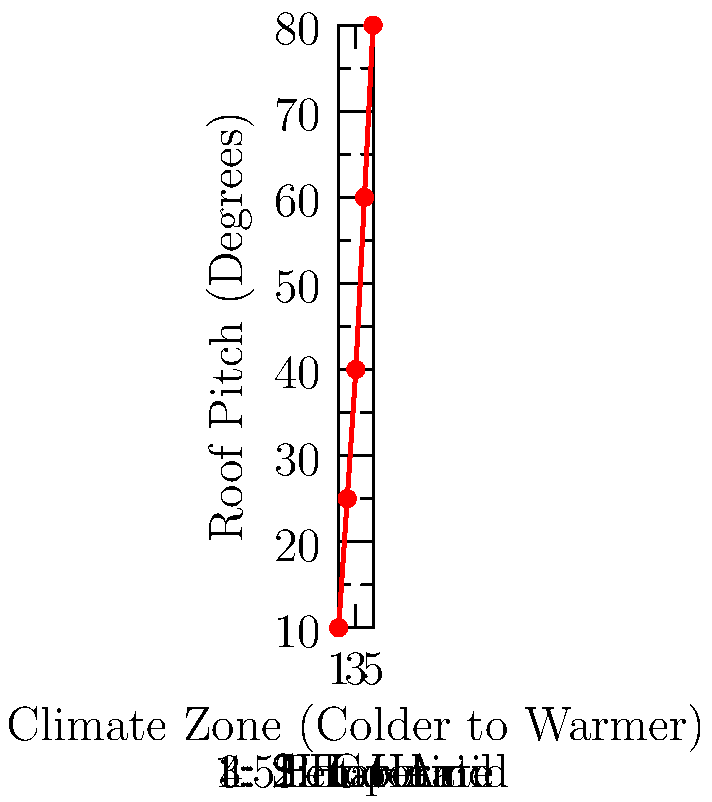Based on the graph showing the relationship between climate zones and roof pitch in American houses, what conclusion can be drawn about the correlation between regional climate and roof styles? To answer this question, let's analyze the graph step-by-step:

1. The x-axis represents climate zones, ranging from colder (1: Subarctic) to warmer (5: Hot-Arid).
2. The y-axis represents roof pitch in degrees, with higher values indicating steeper roofs.
3. The red line shows a clear upward trend from left to right.
4. In the Subarctic zone (1), the roof pitch is approximately 10°.
5. As we move to cooler climates (2), the pitch increases to about 25°.
6. In temperate regions (3), the pitch is around 40°.
7. Hot-Humid areas (4) show a roof pitch of about 60°.
8. Finally, in Hot-Arid regions (5), the roof pitch reaches its maximum at around 80°.

This trend indicates a positive correlation between warmer climates and steeper roof pitches. As we move from colder to warmer regions, the roof pitch increases significantly.

The reason for this correlation likely relates to climate-specific architectural adaptations:
- In colder climates, flatter roofs help retain heat and manage snow loads.
- In warmer climates, especially hot and arid regions, steeper roofs provide better protection from intense sunlight and can assist with natural ventilation.
Answer: Positive correlation: warmer climates have steeper roof pitches. 